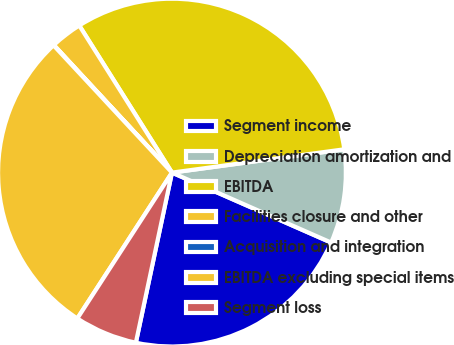Convert chart to OTSL. <chart><loc_0><loc_0><loc_500><loc_500><pie_chart><fcel>Segment income<fcel>Depreciation amortization and<fcel>EBITDA<fcel>Facilities closure and other<fcel>Acquisition and integration<fcel>EBITDA excluding special items<fcel>Segment loss<nl><fcel>21.74%<fcel>8.73%<fcel>31.81%<fcel>2.94%<fcel>0.04%<fcel>28.91%<fcel>5.83%<nl></chart> 